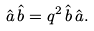<formula> <loc_0><loc_0><loc_500><loc_500>\hat { a } \, \hat { b } = q ^ { 2 } \, \hat { b } \, \hat { a } .</formula> 